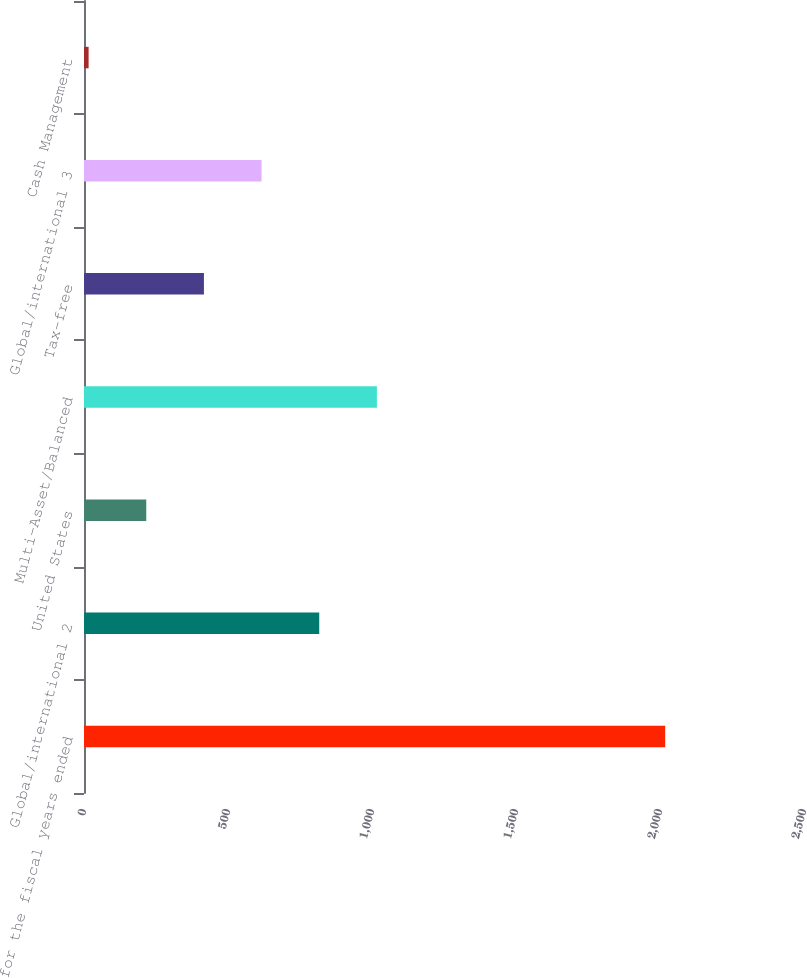Convert chart to OTSL. <chart><loc_0><loc_0><loc_500><loc_500><bar_chart><fcel>for the fiscal years ended<fcel>Global/international 2<fcel>United States<fcel>Multi-Asset/Balanced<fcel>Tax-free<fcel>Global/international 3<fcel>Cash Management<nl><fcel>2018<fcel>816.8<fcel>216.2<fcel>1017<fcel>416.4<fcel>616.6<fcel>16<nl></chart> 